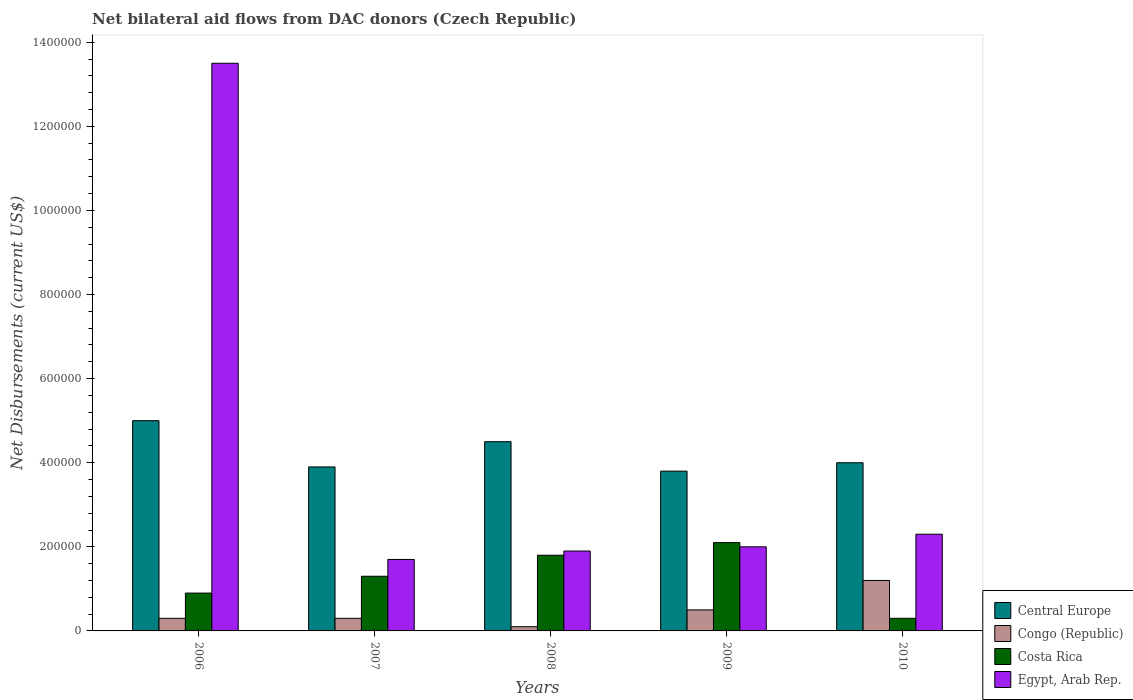In how many cases, is the number of bars for a given year not equal to the number of legend labels?
Give a very brief answer. 0. What is the net bilateral aid flows in Central Europe in 2010?
Your response must be concise. 4.00e+05. Across all years, what is the maximum net bilateral aid flows in Costa Rica?
Give a very brief answer. 2.10e+05. Across all years, what is the minimum net bilateral aid flows in Costa Rica?
Ensure brevity in your answer.  3.00e+04. In which year was the net bilateral aid flows in Central Europe maximum?
Keep it short and to the point. 2006. What is the total net bilateral aid flows in Costa Rica in the graph?
Offer a terse response. 6.40e+05. What is the average net bilateral aid flows in Congo (Republic) per year?
Your answer should be very brief. 4.80e+04. In the year 2006, what is the difference between the net bilateral aid flows in Costa Rica and net bilateral aid flows in Egypt, Arab Rep.?
Give a very brief answer. -1.26e+06. What is the ratio of the net bilateral aid flows in Congo (Republic) in 2009 to that in 2010?
Provide a succinct answer. 0.42. Is the difference between the net bilateral aid flows in Costa Rica in 2006 and 2008 greater than the difference between the net bilateral aid flows in Egypt, Arab Rep. in 2006 and 2008?
Your response must be concise. No. What is the difference between the highest and the second highest net bilateral aid flows in Congo (Republic)?
Offer a terse response. 7.00e+04. Is the sum of the net bilateral aid flows in Costa Rica in 2008 and 2010 greater than the maximum net bilateral aid flows in Egypt, Arab Rep. across all years?
Offer a terse response. No. What does the 1st bar from the left in 2010 represents?
Provide a short and direct response. Central Europe. What does the 3rd bar from the right in 2007 represents?
Offer a very short reply. Congo (Republic). Are the values on the major ticks of Y-axis written in scientific E-notation?
Ensure brevity in your answer.  No. Does the graph contain any zero values?
Give a very brief answer. No. Does the graph contain grids?
Offer a terse response. No. Where does the legend appear in the graph?
Provide a short and direct response. Bottom right. How many legend labels are there?
Provide a succinct answer. 4. What is the title of the graph?
Offer a terse response. Net bilateral aid flows from DAC donors (Czech Republic). What is the label or title of the X-axis?
Ensure brevity in your answer.  Years. What is the label or title of the Y-axis?
Provide a short and direct response. Net Disbursements (current US$). What is the Net Disbursements (current US$) of Central Europe in 2006?
Provide a succinct answer. 5.00e+05. What is the Net Disbursements (current US$) of Congo (Republic) in 2006?
Your answer should be very brief. 3.00e+04. What is the Net Disbursements (current US$) of Egypt, Arab Rep. in 2006?
Make the answer very short. 1.35e+06. What is the Net Disbursements (current US$) of Egypt, Arab Rep. in 2007?
Offer a very short reply. 1.70e+05. What is the Net Disbursements (current US$) of Central Europe in 2009?
Your answer should be very brief. 3.80e+05. What is the Net Disbursements (current US$) in Costa Rica in 2009?
Your response must be concise. 2.10e+05. What is the Net Disbursements (current US$) in Egypt, Arab Rep. in 2009?
Your answer should be very brief. 2.00e+05. What is the Net Disbursements (current US$) in Congo (Republic) in 2010?
Ensure brevity in your answer.  1.20e+05. Across all years, what is the maximum Net Disbursements (current US$) of Costa Rica?
Offer a very short reply. 2.10e+05. Across all years, what is the maximum Net Disbursements (current US$) of Egypt, Arab Rep.?
Your answer should be compact. 1.35e+06. Across all years, what is the minimum Net Disbursements (current US$) in Central Europe?
Keep it short and to the point. 3.80e+05. Across all years, what is the minimum Net Disbursements (current US$) in Congo (Republic)?
Provide a short and direct response. 10000. Across all years, what is the minimum Net Disbursements (current US$) of Egypt, Arab Rep.?
Offer a terse response. 1.70e+05. What is the total Net Disbursements (current US$) of Central Europe in the graph?
Your answer should be very brief. 2.12e+06. What is the total Net Disbursements (current US$) of Congo (Republic) in the graph?
Make the answer very short. 2.40e+05. What is the total Net Disbursements (current US$) of Costa Rica in the graph?
Ensure brevity in your answer.  6.40e+05. What is the total Net Disbursements (current US$) in Egypt, Arab Rep. in the graph?
Offer a very short reply. 2.14e+06. What is the difference between the Net Disbursements (current US$) of Central Europe in 2006 and that in 2007?
Give a very brief answer. 1.10e+05. What is the difference between the Net Disbursements (current US$) of Egypt, Arab Rep. in 2006 and that in 2007?
Ensure brevity in your answer.  1.18e+06. What is the difference between the Net Disbursements (current US$) of Central Europe in 2006 and that in 2008?
Give a very brief answer. 5.00e+04. What is the difference between the Net Disbursements (current US$) of Costa Rica in 2006 and that in 2008?
Provide a short and direct response. -9.00e+04. What is the difference between the Net Disbursements (current US$) in Egypt, Arab Rep. in 2006 and that in 2008?
Keep it short and to the point. 1.16e+06. What is the difference between the Net Disbursements (current US$) of Egypt, Arab Rep. in 2006 and that in 2009?
Your answer should be very brief. 1.15e+06. What is the difference between the Net Disbursements (current US$) in Central Europe in 2006 and that in 2010?
Provide a succinct answer. 1.00e+05. What is the difference between the Net Disbursements (current US$) of Costa Rica in 2006 and that in 2010?
Make the answer very short. 6.00e+04. What is the difference between the Net Disbursements (current US$) in Egypt, Arab Rep. in 2006 and that in 2010?
Your answer should be compact. 1.12e+06. What is the difference between the Net Disbursements (current US$) in Congo (Republic) in 2007 and that in 2008?
Ensure brevity in your answer.  2.00e+04. What is the difference between the Net Disbursements (current US$) in Costa Rica in 2007 and that in 2008?
Provide a short and direct response. -5.00e+04. What is the difference between the Net Disbursements (current US$) of Congo (Republic) in 2007 and that in 2009?
Provide a succinct answer. -2.00e+04. What is the difference between the Net Disbursements (current US$) of Costa Rica in 2007 and that in 2010?
Keep it short and to the point. 1.00e+05. What is the difference between the Net Disbursements (current US$) in Central Europe in 2008 and that in 2009?
Ensure brevity in your answer.  7.00e+04. What is the difference between the Net Disbursements (current US$) of Central Europe in 2008 and that in 2010?
Your response must be concise. 5.00e+04. What is the difference between the Net Disbursements (current US$) of Costa Rica in 2008 and that in 2010?
Your answer should be compact. 1.50e+05. What is the difference between the Net Disbursements (current US$) of Egypt, Arab Rep. in 2008 and that in 2010?
Give a very brief answer. -4.00e+04. What is the difference between the Net Disbursements (current US$) in Central Europe in 2009 and that in 2010?
Ensure brevity in your answer.  -2.00e+04. What is the difference between the Net Disbursements (current US$) in Congo (Republic) in 2009 and that in 2010?
Give a very brief answer. -7.00e+04. What is the difference between the Net Disbursements (current US$) of Central Europe in 2006 and the Net Disbursements (current US$) of Egypt, Arab Rep. in 2007?
Make the answer very short. 3.30e+05. What is the difference between the Net Disbursements (current US$) in Congo (Republic) in 2006 and the Net Disbursements (current US$) in Costa Rica in 2007?
Your answer should be very brief. -1.00e+05. What is the difference between the Net Disbursements (current US$) in Costa Rica in 2006 and the Net Disbursements (current US$) in Egypt, Arab Rep. in 2007?
Provide a short and direct response. -8.00e+04. What is the difference between the Net Disbursements (current US$) of Central Europe in 2006 and the Net Disbursements (current US$) of Congo (Republic) in 2008?
Keep it short and to the point. 4.90e+05. What is the difference between the Net Disbursements (current US$) in Central Europe in 2006 and the Net Disbursements (current US$) in Costa Rica in 2008?
Offer a very short reply. 3.20e+05. What is the difference between the Net Disbursements (current US$) of Congo (Republic) in 2006 and the Net Disbursements (current US$) of Egypt, Arab Rep. in 2008?
Provide a succinct answer. -1.60e+05. What is the difference between the Net Disbursements (current US$) in Congo (Republic) in 2006 and the Net Disbursements (current US$) in Egypt, Arab Rep. in 2009?
Your answer should be very brief. -1.70e+05. What is the difference between the Net Disbursements (current US$) of Central Europe in 2006 and the Net Disbursements (current US$) of Congo (Republic) in 2010?
Offer a terse response. 3.80e+05. What is the difference between the Net Disbursements (current US$) of Central Europe in 2006 and the Net Disbursements (current US$) of Costa Rica in 2010?
Offer a terse response. 4.70e+05. What is the difference between the Net Disbursements (current US$) of Congo (Republic) in 2006 and the Net Disbursements (current US$) of Costa Rica in 2010?
Ensure brevity in your answer.  0. What is the difference between the Net Disbursements (current US$) of Central Europe in 2007 and the Net Disbursements (current US$) of Congo (Republic) in 2008?
Ensure brevity in your answer.  3.80e+05. What is the difference between the Net Disbursements (current US$) in Central Europe in 2007 and the Net Disbursements (current US$) in Egypt, Arab Rep. in 2008?
Your answer should be very brief. 2.00e+05. What is the difference between the Net Disbursements (current US$) in Congo (Republic) in 2007 and the Net Disbursements (current US$) in Egypt, Arab Rep. in 2008?
Make the answer very short. -1.60e+05. What is the difference between the Net Disbursements (current US$) in Central Europe in 2007 and the Net Disbursements (current US$) in Costa Rica in 2009?
Keep it short and to the point. 1.80e+05. What is the difference between the Net Disbursements (current US$) of Congo (Republic) in 2007 and the Net Disbursements (current US$) of Costa Rica in 2009?
Provide a succinct answer. -1.80e+05. What is the difference between the Net Disbursements (current US$) in Congo (Republic) in 2007 and the Net Disbursements (current US$) in Egypt, Arab Rep. in 2009?
Make the answer very short. -1.70e+05. What is the difference between the Net Disbursements (current US$) of Costa Rica in 2007 and the Net Disbursements (current US$) of Egypt, Arab Rep. in 2009?
Make the answer very short. -7.00e+04. What is the difference between the Net Disbursements (current US$) in Central Europe in 2007 and the Net Disbursements (current US$) in Congo (Republic) in 2010?
Provide a succinct answer. 2.70e+05. What is the difference between the Net Disbursements (current US$) in Central Europe in 2007 and the Net Disbursements (current US$) in Costa Rica in 2010?
Offer a very short reply. 3.60e+05. What is the difference between the Net Disbursements (current US$) of Central Europe in 2007 and the Net Disbursements (current US$) of Egypt, Arab Rep. in 2010?
Provide a succinct answer. 1.60e+05. What is the difference between the Net Disbursements (current US$) of Congo (Republic) in 2007 and the Net Disbursements (current US$) of Costa Rica in 2010?
Give a very brief answer. 0. What is the difference between the Net Disbursements (current US$) of Costa Rica in 2007 and the Net Disbursements (current US$) of Egypt, Arab Rep. in 2010?
Provide a succinct answer. -1.00e+05. What is the difference between the Net Disbursements (current US$) in Central Europe in 2008 and the Net Disbursements (current US$) in Costa Rica in 2009?
Provide a succinct answer. 2.40e+05. What is the difference between the Net Disbursements (current US$) of Congo (Republic) in 2008 and the Net Disbursements (current US$) of Egypt, Arab Rep. in 2009?
Provide a succinct answer. -1.90e+05. What is the difference between the Net Disbursements (current US$) in Costa Rica in 2008 and the Net Disbursements (current US$) in Egypt, Arab Rep. in 2010?
Ensure brevity in your answer.  -5.00e+04. What is the difference between the Net Disbursements (current US$) of Central Europe in 2009 and the Net Disbursements (current US$) of Congo (Republic) in 2010?
Your response must be concise. 2.60e+05. What is the difference between the Net Disbursements (current US$) of Central Europe in 2009 and the Net Disbursements (current US$) of Costa Rica in 2010?
Offer a terse response. 3.50e+05. What is the difference between the Net Disbursements (current US$) in Congo (Republic) in 2009 and the Net Disbursements (current US$) in Egypt, Arab Rep. in 2010?
Make the answer very short. -1.80e+05. What is the average Net Disbursements (current US$) in Central Europe per year?
Your answer should be very brief. 4.24e+05. What is the average Net Disbursements (current US$) of Congo (Republic) per year?
Offer a very short reply. 4.80e+04. What is the average Net Disbursements (current US$) in Costa Rica per year?
Provide a short and direct response. 1.28e+05. What is the average Net Disbursements (current US$) in Egypt, Arab Rep. per year?
Provide a short and direct response. 4.28e+05. In the year 2006, what is the difference between the Net Disbursements (current US$) of Central Europe and Net Disbursements (current US$) of Costa Rica?
Make the answer very short. 4.10e+05. In the year 2006, what is the difference between the Net Disbursements (current US$) in Central Europe and Net Disbursements (current US$) in Egypt, Arab Rep.?
Provide a short and direct response. -8.50e+05. In the year 2006, what is the difference between the Net Disbursements (current US$) of Congo (Republic) and Net Disbursements (current US$) of Egypt, Arab Rep.?
Your response must be concise. -1.32e+06. In the year 2006, what is the difference between the Net Disbursements (current US$) of Costa Rica and Net Disbursements (current US$) of Egypt, Arab Rep.?
Give a very brief answer. -1.26e+06. In the year 2007, what is the difference between the Net Disbursements (current US$) of Central Europe and Net Disbursements (current US$) of Costa Rica?
Provide a succinct answer. 2.60e+05. In the year 2007, what is the difference between the Net Disbursements (current US$) in Central Europe and Net Disbursements (current US$) in Egypt, Arab Rep.?
Provide a short and direct response. 2.20e+05. In the year 2007, what is the difference between the Net Disbursements (current US$) in Costa Rica and Net Disbursements (current US$) in Egypt, Arab Rep.?
Give a very brief answer. -4.00e+04. In the year 2008, what is the difference between the Net Disbursements (current US$) in Central Europe and Net Disbursements (current US$) in Egypt, Arab Rep.?
Give a very brief answer. 2.60e+05. In the year 2009, what is the difference between the Net Disbursements (current US$) in Central Europe and Net Disbursements (current US$) in Costa Rica?
Provide a succinct answer. 1.70e+05. In the year 2009, what is the difference between the Net Disbursements (current US$) in Central Europe and Net Disbursements (current US$) in Egypt, Arab Rep.?
Ensure brevity in your answer.  1.80e+05. In the year 2009, what is the difference between the Net Disbursements (current US$) of Costa Rica and Net Disbursements (current US$) of Egypt, Arab Rep.?
Ensure brevity in your answer.  10000. In the year 2010, what is the difference between the Net Disbursements (current US$) in Central Europe and Net Disbursements (current US$) in Costa Rica?
Offer a very short reply. 3.70e+05. What is the ratio of the Net Disbursements (current US$) of Central Europe in 2006 to that in 2007?
Offer a very short reply. 1.28. What is the ratio of the Net Disbursements (current US$) in Congo (Republic) in 2006 to that in 2007?
Provide a short and direct response. 1. What is the ratio of the Net Disbursements (current US$) of Costa Rica in 2006 to that in 2007?
Offer a terse response. 0.69. What is the ratio of the Net Disbursements (current US$) of Egypt, Arab Rep. in 2006 to that in 2007?
Make the answer very short. 7.94. What is the ratio of the Net Disbursements (current US$) of Congo (Republic) in 2006 to that in 2008?
Provide a short and direct response. 3. What is the ratio of the Net Disbursements (current US$) of Egypt, Arab Rep. in 2006 to that in 2008?
Your response must be concise. 7.11. What is the ratio of the Net Disbursements (current US$) in Central Europe in 2006 to that in 2009?
Offer a very short reply. 1.32. What is the ratio of the Net Disbursements (current US$) in Costa Rica in 2006 to that in 2009?
Ensure brevity in your answer.  0.43. What is the ratio of the Net Disbursements (current US$) of Egypt, Arab Rep. in 2006 to that in 2009?
Offer a very short reply. 6.75. What is the ratio of the Net Disbursements (current US$) of Central Europe in 2006 to that in 2010?
Ensure brevity in your answer.  1.25. What is the ratio of the Net Disbursements (current US$) of Congo (Republic) in 2006 to that in 2010?
Offer a very short reply. 0.25. What is the ratio of the Net Disbursements (current US$) of Costa Rica in 2006 to that in 2010?
Offer a terse response. 3. What is the ratio of the Net Disbursements (current US$) in Egypt, Arab Rep. in 2006 to that in 2010?
Your answer should be very brief. 5.87. What is the ratio of the Net Disbursements (current US$) in Central Europe in 2007 to that in 2008?
Offer a very short reply. 0.87. What is the ratio of the Net Disbursements (current US$) of Congo (Republic) in 2007 to that in 2008?
Provide a short and direct response. 3. What is the ratio of the Net Disbursements (current US$) in Costa Rica in 2007 to that in 2008?
Provide a succinct answer. 0.72. What is the ratio of the Net Disbursements (current US$) of Egypt, Arab Rep. in 2007 to that in 2008?
Keep it short and to the point. 0.89. What is the ratio of the Net Disbursements (current US$) in Central Europe in 2007 to that in 2009?
Your response must be concise. 1.03. What is the ratio of the Net Disbursements (current US$) of Congo (Republic) in 2007 to that in 2009?
Offer a terse response. 0.6. What is the ratio of the Net Disbursements (current US$) of Costa Rica in 2007 to that in 2009?
Provide a short and direct response. 0.62. What is the ratio of the Net Disbursements (current US$) of Central Europe in 2007 to that in 2010?
Provide a short and direct response. 0.97. What is the ratio of the Net Disbursements (current US$) of Costa Rica in 2007 to that in 2010?
Offer a very short reply. 4.33. What is the ratio of the Net Disbursements (current US$) of Egypt, Arab Rep. in 2007 to that in 2010?
Make the answer very short. 0.74. What is the ratio of the Net Disbursements (current US$) of Central Europe in 2008 to that in 2009?
Your answer should be very brief. 1.18. What is the ratio of the Net Disbursements (current US$) of Congo (Republic) in 2008 to that in 2009?
Provide a succinct answer. 0.2. What is the ratio of the Net Disbursements (current US$) in Congo (Republic) in 2008 to that in 2010?
Provide a succinct answer. 0.08. What is the ratio of the Net Disbursements (current US$) of Costa Rica in 2008 to that in 2010?
Your answer should be very brief. 6. What is the ratio of the Net Disbursements (current US$) in Egypt, Arab Rep. in 2008 to that in 2010?
Give a very brief answer. 0.83. What is the ratio of the Net Disbursements (current US$) in Central Europe in 2009 to that in 2010?
Offer a very short reply. 0.95. What is the ratio of the Net Disbursements (current US$) in Congo (Republic) in 2009 to that in 2010?
Provide a succinct answer. 0.42. What is the ratio of the Net Disbursements (current US$) in Egypt, Arab Rep. in 2009 to that in 2010?
Your response must be concise. 0.87. What is the difference between the highest and the second highest Net Disbursements (current US$) of Congo (Republic)?
Make the answer very short. 7.00e+04. What is the difference between the highest and the second highest Net Disbursements (current US$) of Costa Rica?
Offer a very short reply. 3.00e+04. What is the difference between the highest and the second highest Net Disbursements (current US$) in Egypt, Arab Rep.?
Make the answer very short. 1.12e+06. What is the difference between the highest and the lowest Net Disbursements (current US$) in Congo (Republic)?
Provide a short and direct response. 1.10e+05. What is the difference between the highest and the lowest Net Disbursements (current US$) in Costa Rica?
Your answer should be compact. 1.80e+05. What is the difference between the highest and the lowest Net Disbursements (current US$) in Egypt, Arab Rep.?
Your answer should be very brief. 1.18e+06. 